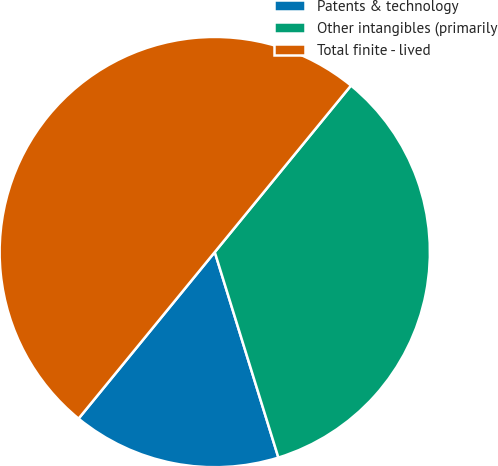Convert chart to OTSL. <chart><loc_0><loc_0><loc_500><loc_500><pie_chart><fcel>Patents & technology<fcel>Other intangibles (primarily<fcel>Total finite - lived<nl><fcel>15.69%<fcel>34.31%<fcel>50.0%<nl></chart> 